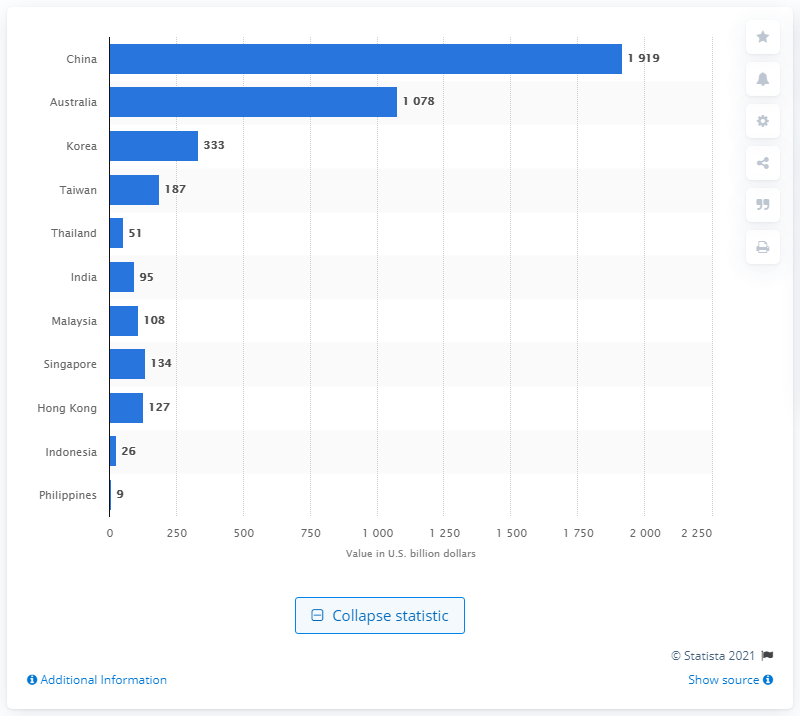Give some essential details in this illustration. In 2014, the mortgage loans granted by banks in India amounted to approximately $95 billion in US dollars. 